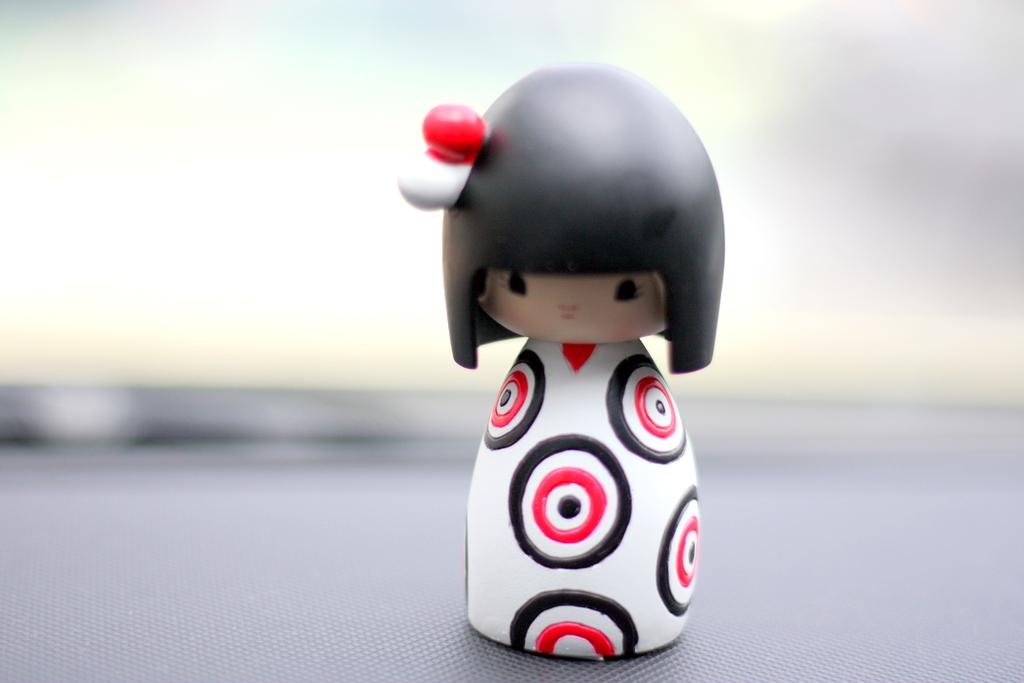What is the main subject of the image? There is a toy in the image. Can you describe the background of the toy? The background of the toy is blurred. Can you tell me how many knees are visible in the image? There are no knees visible in the image; it features a toy with a blurred background. What type of park can be seen in the image? There is no park present in the image; it features a toy with a blurred background. 